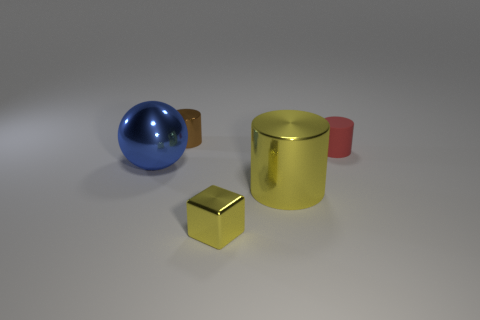What number of objects are big shiny things or small brown cylinders?
Offer a very short reply. 3. What number of other objects are there of the same shape as the big blue metallic object?
Keep it short and to the point. 0. Is the material of the big object that is right of the blue thing the same as the cylinder behind the tiny matte object?
Give a very brief answer. Yes. There is a tiny thing that is behind the small yellow cube and left of the tiny red cylinder; what is its shape?
Offer a very short reply. Cylinder. Are there any other things that have the same material as the brown object?
Give a very brief answer. Yes. There is a small thing that is both behind the tiny metallic block and on the right side of the brown thing; what material is it?
Offer a terse response. Rubber. What is the shape of the large yellow thing that is made of the same material as the small brown thing?
Keep it short and to the point. Cylinder. Are there any other things that have the same color as the large sphere?
Your response must be concise. No. Is the number of tiny yellow cubes that are to the right of the matte cylinder greater than the number of red objects?
Provide a short and direct response. No. What material is the tiny red cylinder?
Ensure brevity in your answer.  Rubber. 